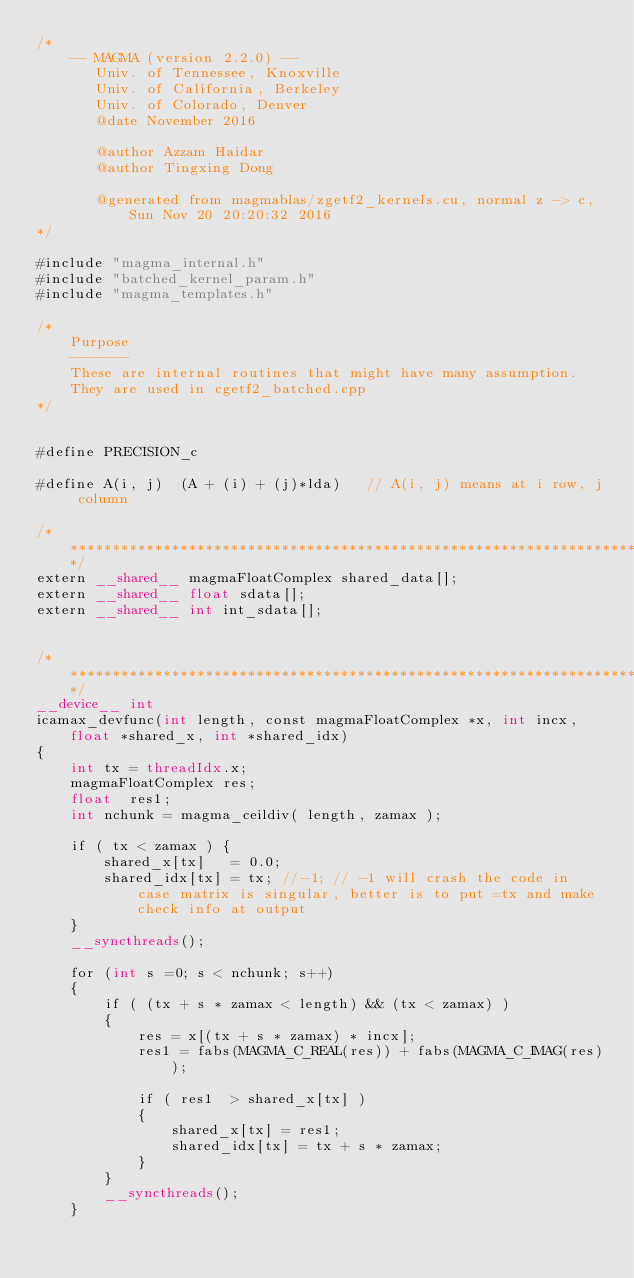Convert code to text. <code><loc_0><loc_0><loc_500><loc_500><_Cuda_>/*
    -- MAGMA (version 2.2.0) --
       Univ. of Tennessee, Knoxville
       Univ. of California, Berkeley
       Univ. of Colorado, Denver
       @date November 2016

       @author Azzam Haidar
       @author Tingxing Dong

       @generated from magmablas/zgetf2_kernels.cu, normal z -> c, Sun Nov 20 20:20:32 2016
*/

#include "magma_internal.h"
#include "batched_kernel_param.h"
#include "magma_templates.h"

/*
    Purpose
    -------
    These are internal routines that might have many assumption.
    They are used in cgetf2_batched.cpp
*/


#define PRECISION_c

#define A(i, j)  (A + (i) + (j)*lda)   // A(i, j) means at i row, j column

/******************************************************************************/
extern __shared__ magmaFloatComplex shared_data[];
extern __shared__ float sdata[];
extern __shared__ int int_sdata[];


/******************************************************************************/
__device__ int
icamax_devfunc(int length, const magmaFloatComplex *x, int incx, float *shared_x, int *shared_idx)
{
    int tx = threadIdx.x;
    magmaFloatComplex res;
    float  res1;
    int nchunk = magma_ceildiv( length, zamax );

    if ( tx < zamax ) {
        shared_x[tx]   = 0.0;
        shared_idx[tx] = tx; //-1; // -1 will crash the code in case matrix is singular, better is to put =tx and make check info at output
    }
    __syncthreads();

    for (int s =0; s < nchunk; s++)
    {
        if ( (tx + s * zamax < length) && (tx < zamax) )
        {
            res = x[(tx + s * zamax) * incx];
            res1 = fabs(MAGMA_C_REAL(res)) + fabs(MAGMA_C_IMAG(res));

            if ( res1  > shared_x[tx] )
            {
                shared_x[tx] = res1;
                shared_idx[tx] = tx + s * zamax;
            }
        }
        __syncthreads();
    }
</code> 